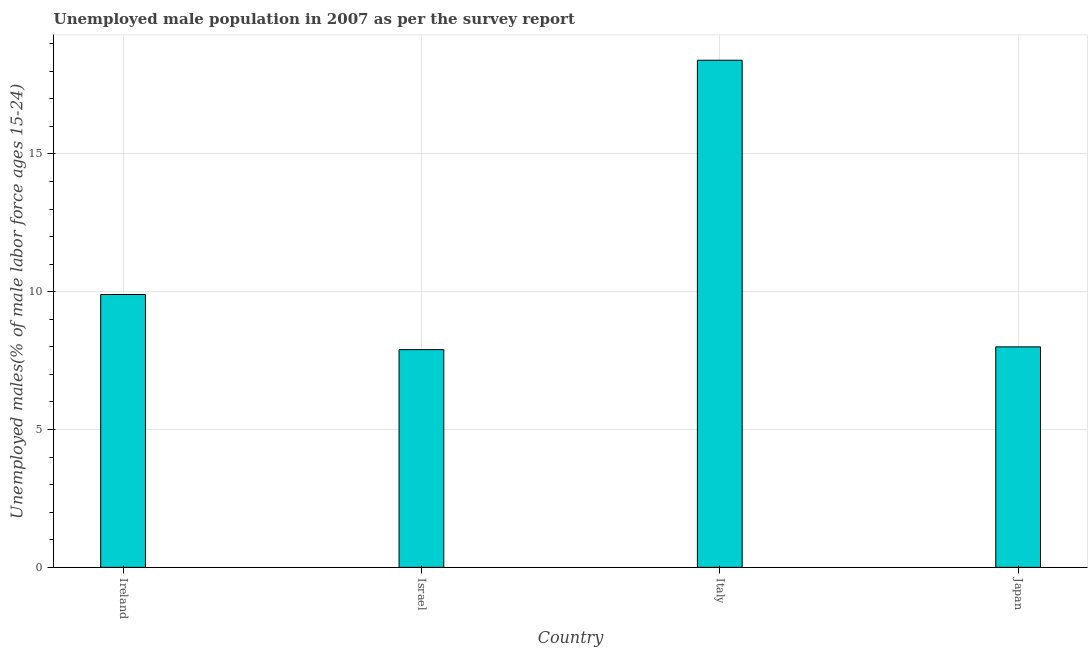Does the graph contain grids?
Provide a short and direct response. Yes. What is the title of the graph?
Provide a succinct answer. Unemployed male population in 2007 as per the survey report. What is the label or title of the X-axis?
Offer a very short reply. Country. What is the label or title of the Y-axis?
Make the answer very short. Unemployed males(% of male labor force ages 15-24). What is the unemployed male youth in Israel?
Offer a very short reply. 7.9. Across all countries, what is the maximum unemployed male youth?
Offer a very short reply. 18.4. Across all countries, what is the minimum unemployed male youth?
Give a very brief answer. 7.9. In which country was the unemployed male youth minimum?
Your answer should be compact. Israel. What is the sum of the unemployed male youth?
Your response must be concise. 44.2. What is the average unemployed male youth per country?
Your answer should be very brief. 11.05. What is the median unemployed male youth?
Offer a terse response. 8.95. What is the ratio of the unemployed male youth in Ireland to that in Italy?
Your answer should be very brief. 0.54. Is the unemployed male youth in Ireland less than that in Japan?
Provide a short and direct response. No. Is the difference between the unemployed male youth in Ireland and Japan greater than the difference between any two countries?
Offer a very short reply. No. What is the difference between the highest and the second highest unemployed male youth?
Make the answer very short. 8.5. Is the sum of the unemployed male youth in Israel and Italy greater than the maximum unemployed male youth across all countries?
Keep it short and to the point. Yes. In how many countries, is the unemployed male youth greater than the average unemployed male youth taken over all countries?
Your response must be concise. 1. How many bars are there?
Ensure brevity in your answer.  4. How many countries are there in the graph?
Give a very brief answer. 4. What is the difference between two consecutive major ticks on the Y-axis?
Your answer should be very brief. 5. What is the Unemployed males(% of male labor force ages 15-24) in Ireland?
Offer a very short reply. 9.9. What is the Unemployed males(% of male labor force ages 15-24) in Israel?
Provide a succinct answer. 7.9. What is the Unemployed males(% of male labor force ages 15-24) of Italy?
Your answer should be compact. 18.4. What is the Unemployed males(% of male labor force ages 15-24) of Japan?
Your response must be concise. 8. What is the ratio of the Unemployed males(% of male labor force ages 15-24) in Ireland to that in Israel?
Provide a short and direct response. 1.25. What is the ratio of the Unemployed males(% of male labor force ages 15-24) in Ireland to that in Italy?
Your response must be concise. 0.54. What is the ratio of the Unemployed males(% of male labor force ages 15-24) in Ireland to that in Japan?
Make the answer very short. 1.24. What is the ratio of the Unemployed males(% of male labor force ages 15-24) in Israel to that in Italy?
Offer a terse response. 0.43. What is the ratio of the Unemployed males(% of male labor force ages 15-24) in Italy to that in Japan?
Keep it short and to the point. 2.3. 